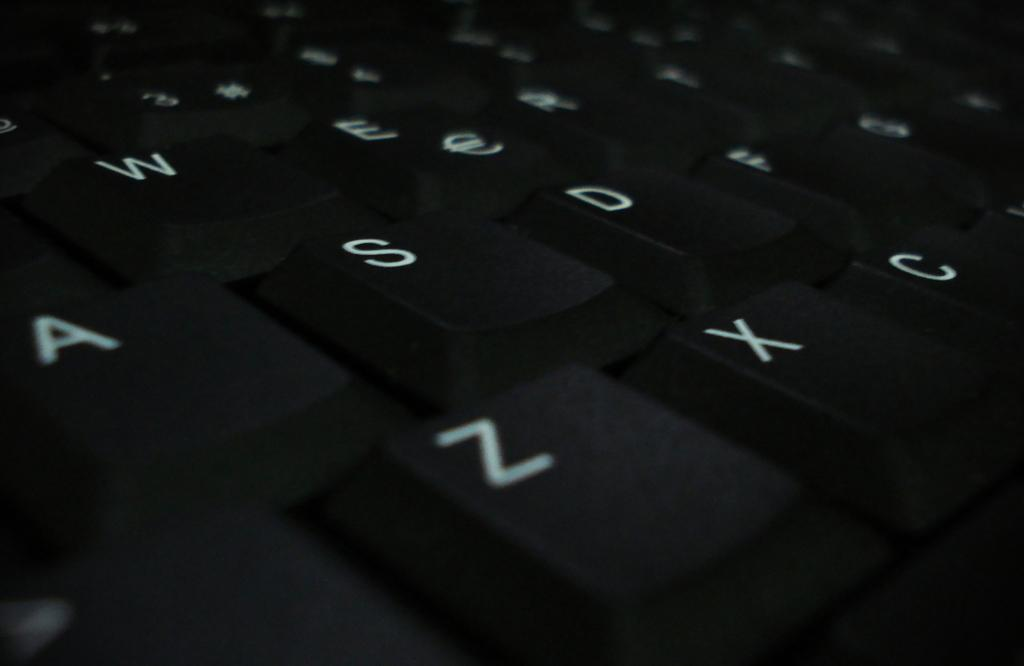<image>
Provide a brief description of the given image. Black keyboard that has the X key between the Z and C key. 